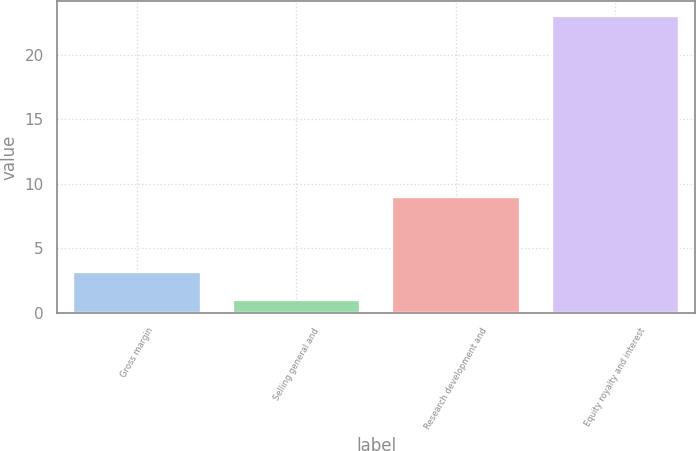<chart> <loc_0><loc_0><loc_500><loc_500><bar_chart><fcel>Gross margin<fcel>Selling general and<fcel>Research development and<fcel>Equity royalty and interest<nl><fcel>3.2<fcel>1<fcel>9<fcel>23<nl></chart> 